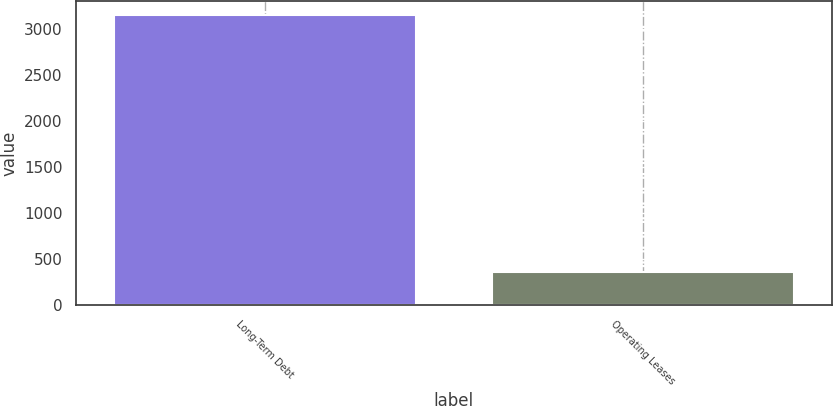<chart> <loc_0><loc_0><loc_500><loc_500><bar_chart><fcel>Long-Term Debt<fcel>Operating Leases<nl><fcel>3149<fcel>366<nl></chart> 